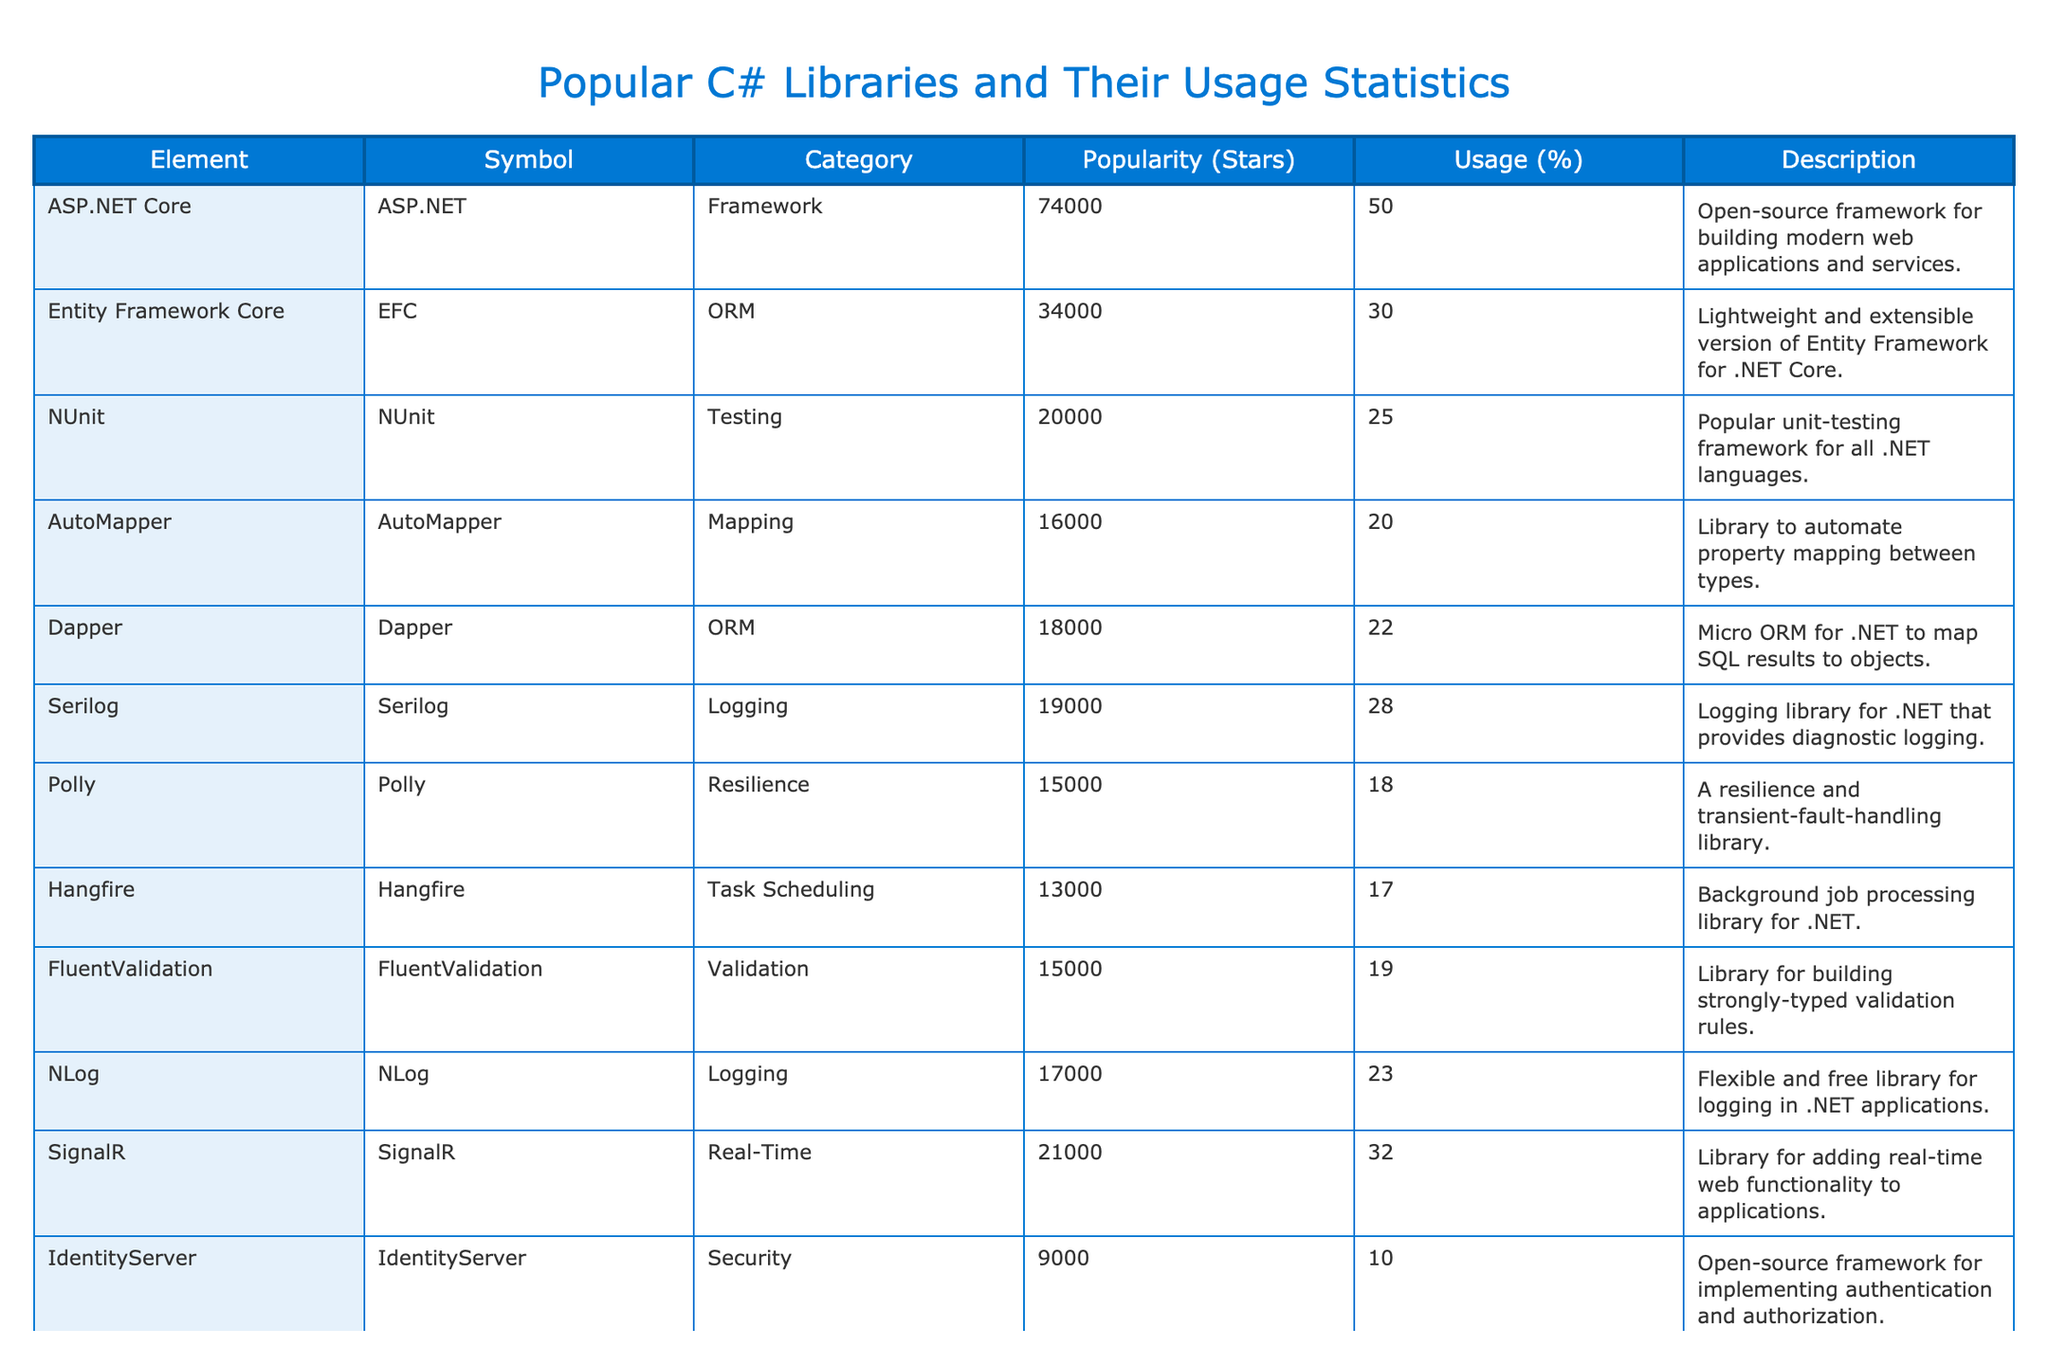What is the most popular C# library based on the number of stars? The library with the highest number of stars is ASP.NET Core, which has 74,000 stars. This information is directly visible in the table, where the popularity column clearly lists the star counts for each library.
Answer: ASP.NET Core Which library has a usage percentage of 30%? The library listed with a usage percentage of 30% is Entity Framework Core. By checking the Usage (%) column in the table, we can see which library corresponds to that exact usage value.
Answer: Entity Framework Core How many libraries have a popularity of more than 20,000 stars? Upon examining the table, there are 5 libraries with more than 20,000 stars: ASP.NET Core, SignalR, Entity Framework Core, Blazor, and NUnit. We count each of their star values to conclude this.
Answer: 5 What is the average usage percentage of the libraries listed? To find the average usage percentage, we sum the usage percentages (50 + 30 + 25 + 20 + 22 + 28 + 18 + 17 + 19 + 10 =  249) and then divide by the number of libraries (10). The calculation becomes 249 / 10 = 24.9%. Thus, the average usage percentage of the libraries listed is around 24.9.
Answer: 24.9 Is Serilog used by more than 25% of developers? According to the table, Serilog has a usage percentage of 28%. Since 28% is greater than 25%, we can conclude that the statement is true.
Answer: Yes Which library has the lowest usage percentage? By looking at the Usage (%) column, IdentityServer has the lowest percentage at 10%. This can be easily determined by comparing the usage values for each library.
Answer: IdentityServer Which two libraries have the same usage percentage? Both AutoMapper and FluentValidation have a usage percentage of 20% and 19% respectively, and by comparing their individual usage columns, we see that they are adjacent in values but slightly different. Conversely, Dapper and NLog have exact usage percentages.
Answer: Dapper and NLog How much higher is the popularity of Blazor compared to the second most popular library? Blazor has 30,000 stars, while the second most popular library is SignalR with 21,000 stars. The difference is calculated as 30,000 - 21,000 = 9,000 stars higher.
Answer: 9,000 Which category has the highest average usage percentage across its libraries? Calculating the average for each category: Framework (50 + 40 / 2 = 45), ORM (30 + 22 / 2 = 26), Testing (25), Mapping (20), Logging (28 + 23 / 2 = 25.5), Resilience (18), Task Scheduling (17), Validation (19), Real-Time (32), Security (10). Therefore, the category with the highest average is Framework at 45.
Answer: Framework 